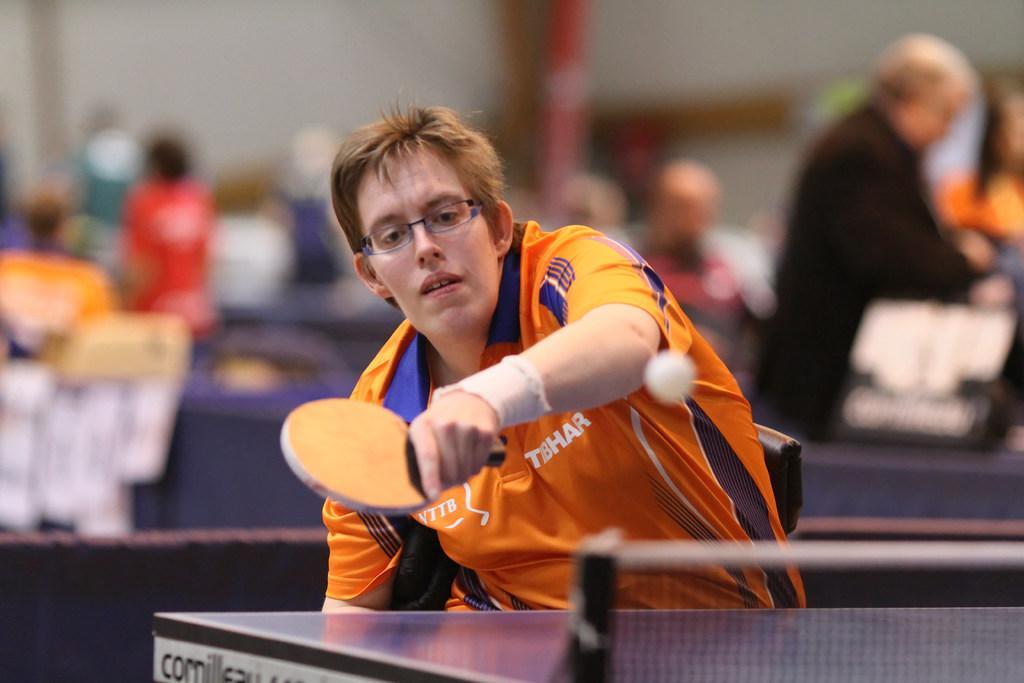Could you give a brief overview of what you see in this image? In this picture we can see a person wore a spectacle and holding a table tennis bat, ball is in the air, table tennis table and in the background we can see a group of people, some objects, wall and it is blurry. 